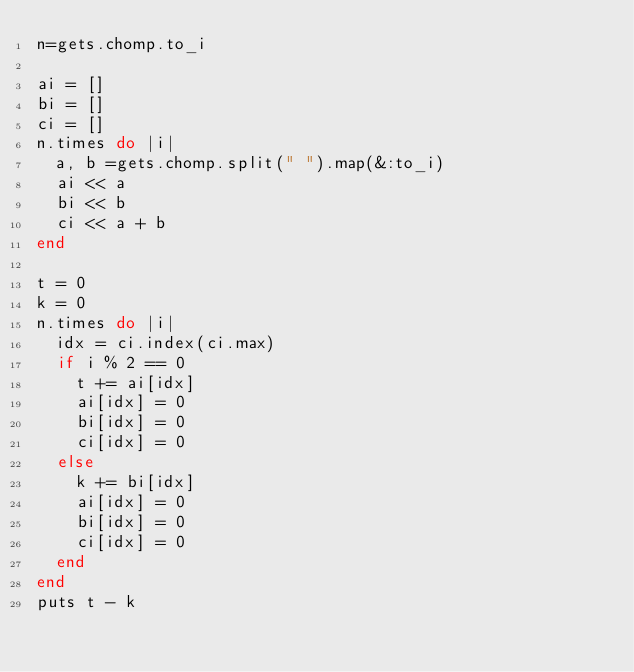Convert code to text. <code><loc_0><loc_0><loc_500><loc_500><_Ruby_>n=gets.chomp.to_i

ai = []
bi = []
ci = []
n.times do |i|
  a, b =gets.chomp.split(" ").map(&:to_i)
  ai << a
  bi << b
  ci << a + b
end

t = 0
k = 0
n.times do |i|
  idx = ci.index(ci.max)
  if i % 2 == 0
    t += ai[idx]
    ai[idx] = 0
    bi[idx] = 0
    ci[idx] = 0
  else
    k += bi[idx]
    ai[idx] = 0
    bi[idx] = 0
    ci[idx] = 0
  end
end
puts t - k </code> 